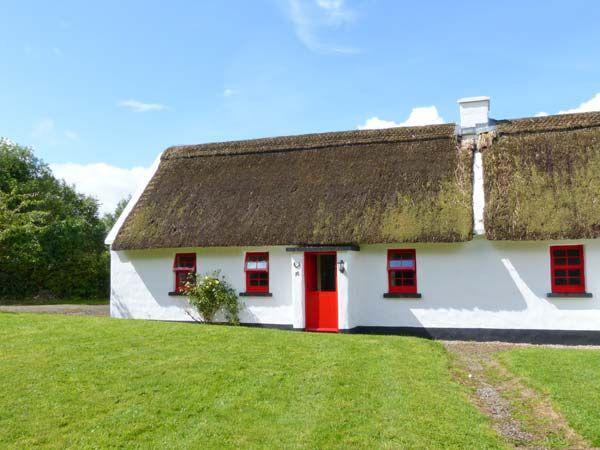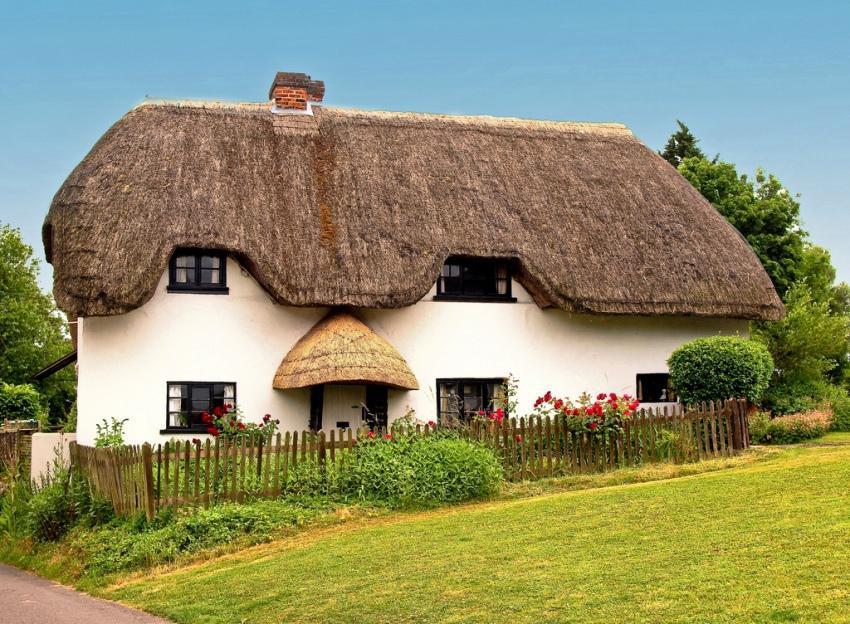The first image is the image on the left, the second image is the image on the right. For the images displayed, is the sentence "There are two windows on the left side of the door in at least one of the pictures." factually correct? Answer yes or no. Yes. 